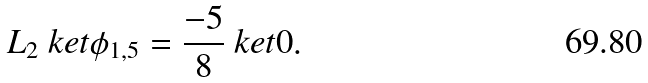Convert formula to latex. <formula><loc_0><loc_0><loc_500><loc_500>L _ { 2 } \ k e t { \phi _ { 1 , 5 } } = \frac { - 5 } { 8 } \ k e t { 0 } .</formula> 